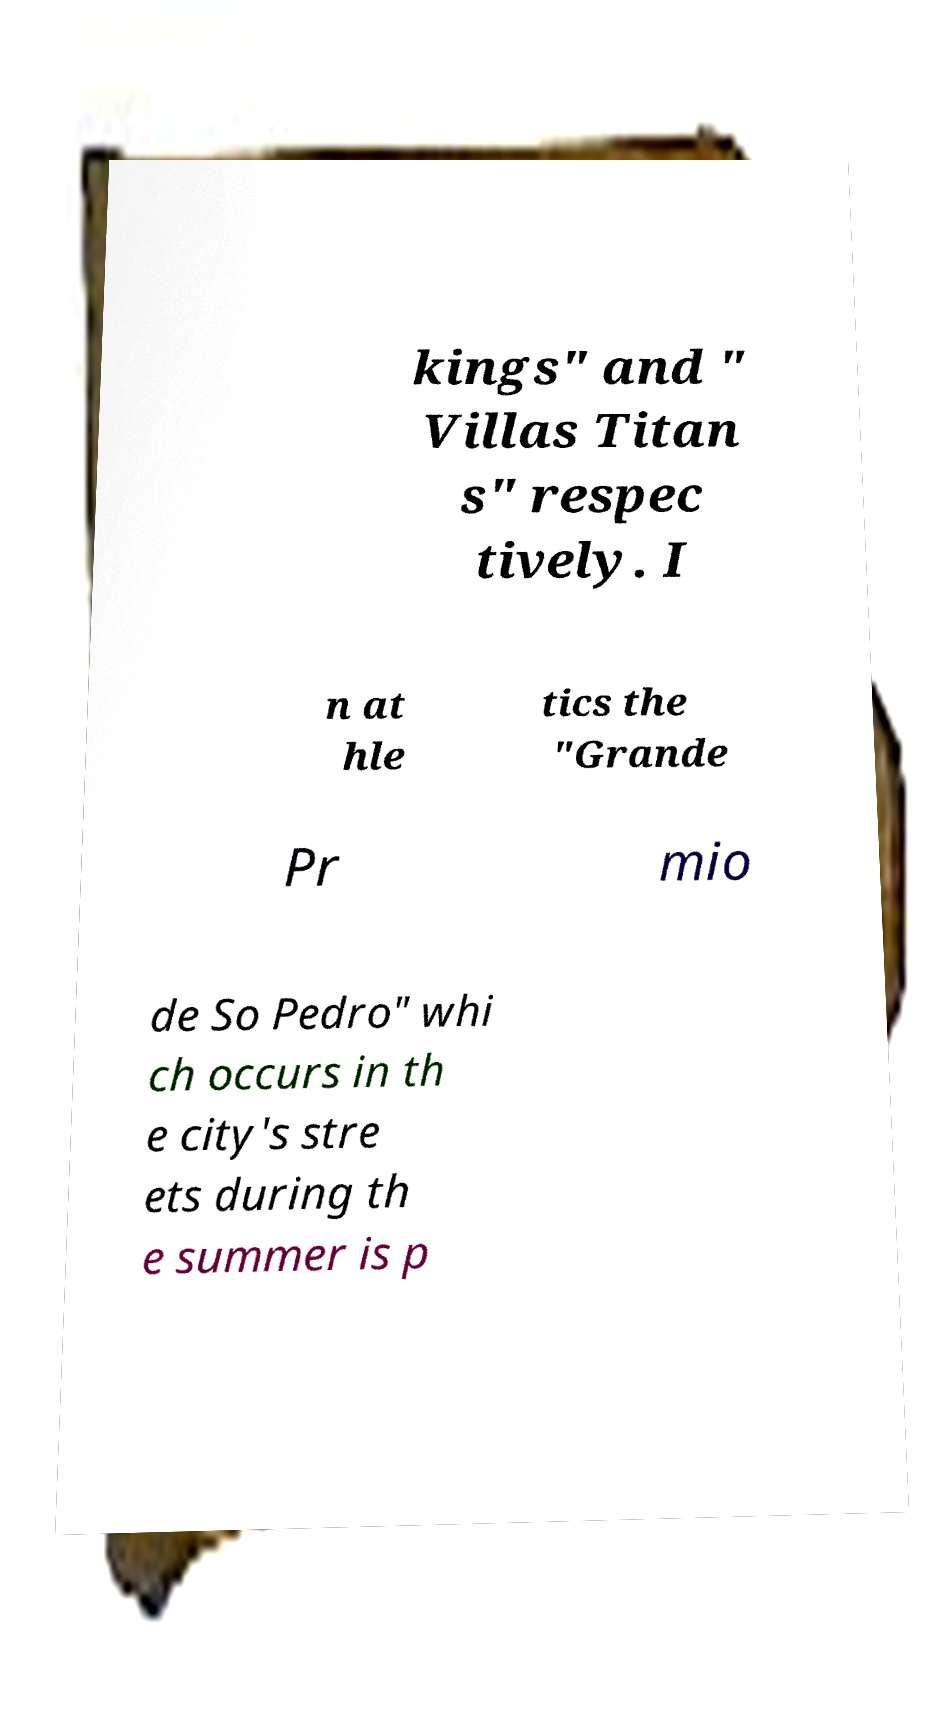Could you assist in decoding the text presented in this image and type it out clearly? kings" and " Villas Titan s" respec tively. I n at hle tics the "Grande Pr mio de So Pedro" whi ch occurs in th e city's stre ets during th e summer is p 